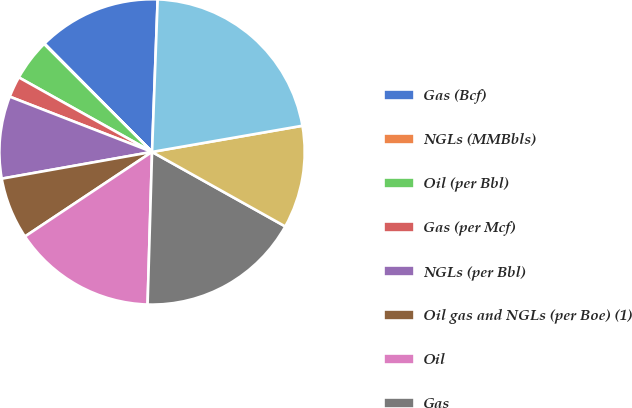Convert chart. <chart><loc_0><loc_0><loc_500><loc_500><pie_chart><fcel>Gas (Bcf)<fcel>NGLs (MMBbls)<fcel>Oil (per Bbl)<fcel>Gas (per Mcf)<fcel>NGLs (per Bbl)<fcel>Oil gas and NGLs (per Boe) (1)<fcel>Oil<fcel>Gas<fcel>NGLs<fcel>Oil gas and NGLs<nl><fcel>13.03%<fcel>0.06%<fcel>4.38%<fcel>2.22%<fcel>8.7%<fcel>6.54%<fcel>15.19%<fcel>17.35%<fcel>10.86%<fcel>21.67%<nl></chart> 